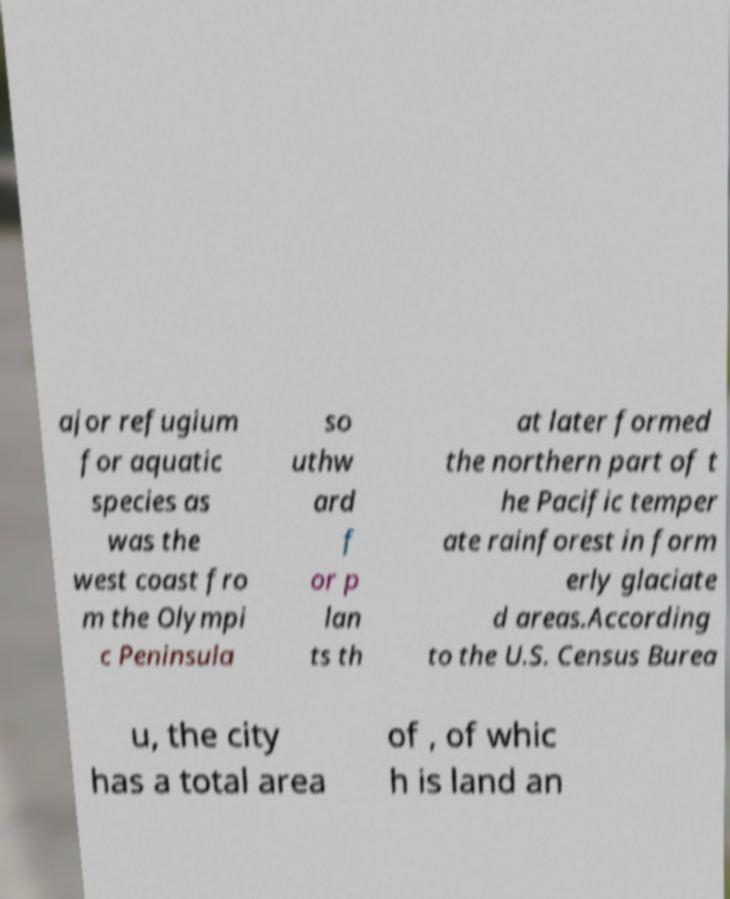What messages or text are displayed in this image? I need them in a readable, typed format. ajor refugium for aquatic species as was the west coast fro m the Olympi c Peninsula so uthw ard f or p lan ts th at later formed the northern part of t he Pacific temper ate rainforest in form erly glaciate d areas.According to the U.S. Census Burea u, the city has a total area of , of whic h is land an 